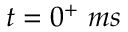Convert formula to latex. <formula><loc_0><loc_0><loc_500><loc_500>t = 0 ^ { + } m s</formula> 